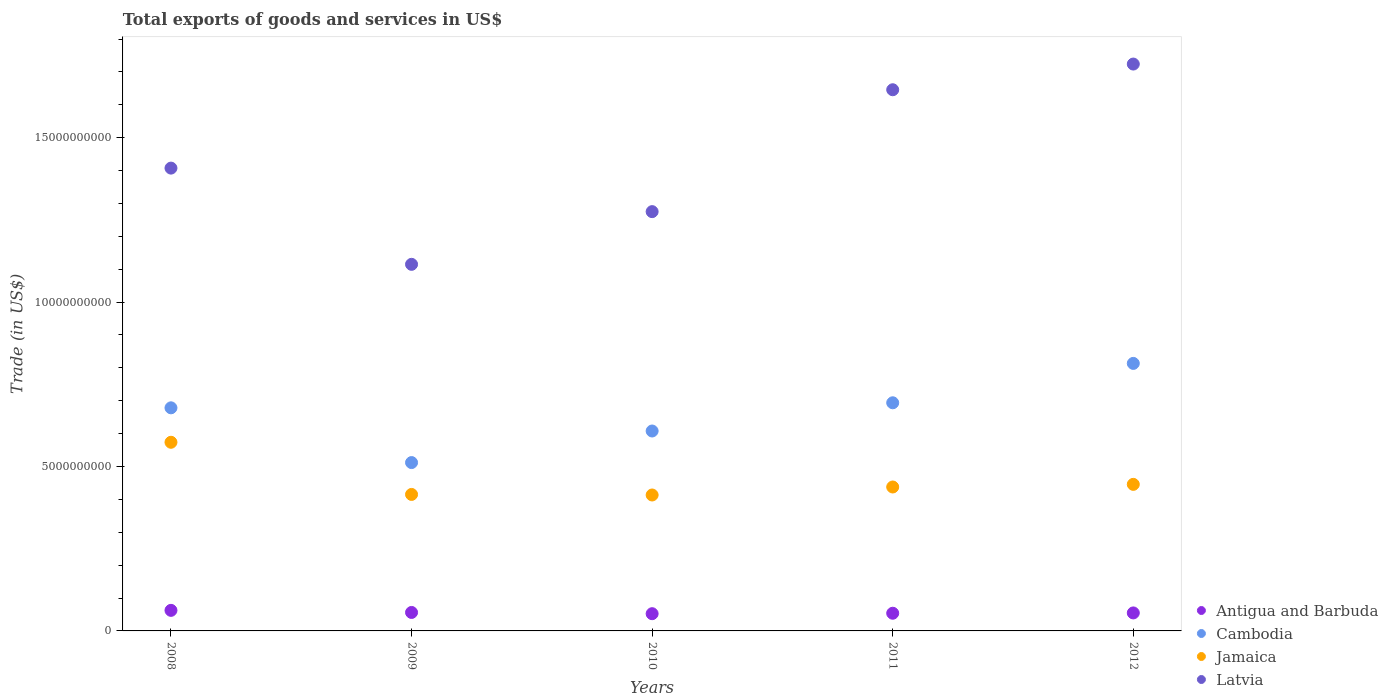Is the number of dotlines equal to the number of legend labels?
Your answer should be compact. Yes. What is the total exports of goods and services in Jamaica in 2010?
Your answer should be compact. 4.13e+09. Across all years, what is the maximum total exports of goods and services in Latvia?
Give a very brief answer. 1.72e+1. Across all years, what is the minimum total exports of goods and services in Antigua and Barbuda?
Your answer should be very brief. 5.24e+08. What is the total total exports of goods and services in Cambodia in the graph?
Keep it short and to the point. 3.31e+1. What is the difference between the total exports of goods and services in Antigua and Barbuda in 2011 and that in 2012?
Provide a succinct answer. -9.44e+06. What is the difference between the total exports of goods and services in Latvia in 2010 and the total exports of goods and services in Antigua and Barbuda in 2012?
Make the answer very short. 1.22e+1. What is the average total exports of goods and services in Jamaica per year?
Your answer should be very brief. 4.57e+09. In the year 2010, what is the difference between the total exports of goods and services in Jamaica and total exports of goods and services in Latvia?
Provide a short and direct response. -8.62e+09. What is the ratio of the total exports of goods and services in Jamaica in 2011 to that in 2012?
Make the answer very short. 0.98. Is the total exports of goods and services in Antigua and Barbuda in 2010 less than that in 2012?
Ensure brevity in your answer.  Yes. Is the difference between the total exports of goods and services in Jamaica in 2008 and 2009 greater than the difference between the total exports of goods and services in Latvia in 2008 and 2009?
Ensure brevity in your answer.  No. What is the difference between the highest and the second highest total exports of goods and services in Antigua and Barbuda?
Ensure brevity in your answer.  6.37e+07. What is the difference between the highest and the lowest total exports of goods and services in Latvia?
Give a very brief answer. 6.09e+09. Is it the case that in every year, the sum of the total exports of goods and services in Antigua and Barbuda and total exports of goods and services in Jamaica  is greater than the sum of total exports of goods and services in Latvia and total exports of goods and services in Cambodia?
Offer a terse response. No. Does the total exports of goods and services in Antigua and Barbuda monotonically increase over the years?
Give a very brief answer. No. Is the total exports of goods and services in Latvia strictly greater than the total exports of goods and services in Antigua and Barbuda over the years?
Make the answer very short. Yes. Is the total exports of goods and services in Latvia strictly less than the total exports of goods and services in Antigua and Barbuda over the years?
Your answer should be very brief. No. What is the difference between two consecutive major ticks on the Y-axis?
Your answer should be very brief. 5.00e+09. Are the values on the major ticks of Y-axis written in scientific E-notation?
Offer a terse response. No. Does the graph contain any zero values?
Offer a terse response. No. How are the legend labels stacked?
Your answer should be compact. Vertical. What is the title of the graph?
Provide a succinct answer. Total exports of goods and services in US$. What is the label or title of the Y-axis?
Your answer should be compact. Trade (in US$). What is the Trade (in US$) of Antigua and Barbuda in 2008?
Your answer should be compact. 6.25e+08. What is the Trade (in US$) of Cambodia in 2008?
Ensure brevity in your answer.  6.78e+09. What is the Trade (in US$) in Jamaica in 2008?
Keep it short and to the point. 5.74e+09. What is the Trade (in US$) in Latvia in 2008?
Provide a short and direct response. 1.41e+1. What is the Trade (in US$) in Antigua and Barbuda in 2009?
Ensure brevity in your answer.  5.62e+08. What is the Trade (in US$) of Cambodia in 2009?
Offer a terse response. 5.12e+09. What is the Trade (in US$) of Jamaica in 2009?
Provide a succinct answer. 4.15e+09. What is the Trade (in US$) in Latvia in 2009?
Your answer should be very brief. 1.11e+1. What is the Trade (in US$) in Antigua and Barbuda in 2010?
Keep it short and to the point. 5.24e+08. What is the Trade (in US$) in Cambodia in 2010?
Your response must be concise. 6.08e+09. What is the Trade (in US$) in Jamaica in 2010?
Your answer should be compact. 4.13e+09. What is the Trade (in US$) in Latvia in 2010?
Your response must be concise. 1.28e+1. What is the Trade (in US$) of Antigua and Barbuda in 2011?
Your answer should be compact. 5.38e+08. What is the Trade (in US$) in Cambodia in 2011?
Give a very brief answer. 6.94e+09. What is the Trade (in US$) in Jamaica in 2011?
Provide a succinct answer. 4.38e+09. What is the Trade (in US$) in Latvia in 2011?
Give a very brief answer. 1.65e+1. What is the Trade (in US$) of Antigua and Barbuda in 2012?
Make the answer very short. 5.47e+08. What is the Trade (in US$) of Cambodia in 2012?
Provide a short and direct response. 8.14e+09. What is the Trade (in US$) in Jamaica in 2012?
Offer a very short reply. 4.46e+09. What is the Trade (in US$) in Latvia in 2012?
Provide a succinct answer. 1.72e+1. Across all years, what is the maximum Trade (in US$) of Antigua and Barbuda?
Provide a succinct answer. 6.25e+08. Across all years, what is the maximum Trade (in US$) in Cambodia?
Make the answer very short. 8.14e+09. Across all years, what is the maximum Trade (in US$) in Jamaica?
Offer a terse response. 5.74e+09. Across all years, what is the maximum Trade (in US$) in Latvia?
Offer a terse response. 1.72e+1. Across all years, what is the minimum Trade (in US$) in Antigua and Barbuda?
Make the answer very short. 5.24e+08. Across all years, what is the minimum Trade (in US$) in Cambodia?
Make the answer very short. 5.12e+09. Across all years, what is the minimum Trade (in US$) in Jamaica?
Offer a very short reply. 4.13e+09. Across all years, what is the minimum Trade (in US$) in Latvia?
Your answer should be very brief. 1.11e+1. What is the total Trade (in US$) of Antigua and Barbuda in the graph?
Provide a short and direct response. 2.80e+09. What is the total Trade (in US$) in Cambodia in the graph?
Provide a succinct answer. 3.31e+1. What is the total Trade (in US$) in Jamaica in the graph?
Ensure brevity in your answer.  2.29e+1. What is the total Trade (in US$) of Latvia in the graph?
Give a very brief answer. 7.17e+1. What is the difference between the Trade (in US$) of Antigua and Barbuda in 2008 and that in 2009?
Keep it short and to the point. 6.37e+07. What is the difference between the Trade (in US$) of Cambodia in 2008 and that in 2009?
Your answer should be compact. 1.67e+09. What is the difference between the Trade (in US$) of Jamaica in 2008 and that in 2009?
Give a very brief answer. 1.59e+09. What is the difference between the Trade (in US$) of Latvia in 2008 and that in 2009?
Keep it short and to the point. 2.93e+09. What is the difference between the Trade (in US$) in Antigua and Barbuda in 2008 and that in 2010?
Your response must be concise. 1.02e+08. What is the difference between the Trade (in US$) in Cambodia in 2008 and that in 2010?
Ensure brevity in your answer.  7.05e+08. What is the difference between the Trade (in US$) in Jamaica in 2008 and that in 2010?
Keep it short and to the point. 1.60e+09. What is the difference between the Trade (in US$) of Latvia in 2008 and that in 2010?
Make the answer very short. 1.32e+09. What is the difference between the Trade (in US$) in Antigua and Barbuda in 2008 and that in 2011?
Provide a succinct answer. 8.76e+07. What is the difference between the Trade (in US$) of Cambodia in 2008 and that in 2011?
Your answer should be very brief. -1.53e+08. What is the difference between the Trade (in US$) in Jamaica in 2008 and that in 2011?
Your response must be concise. 1.36e+09. What is the difference between the Trade (in US$) in Latvia in 2008 and that in 2011?
Provide a short and direct response. -2.38e+09. What is the difference between the Trade (in US$) in Antigua and Barbuda in 2008 and that in 2012?
Your response must be concise. 7.82e+07. What is the difference between the Trade (in US$) in Cambodia in 2008 and that in 2012?
Provide a succinct answer. -1.35e+09. What is the difference between the Trade (in US$) in Jamaica in 2008 and that in 2012?
Give a very brief answer. 1.28e+09. What is the difference between the Trade (in US$) of Latvia in 2008 and that in 2012?
Offer a terse response. -3.16e+09. What is the difference between the Trade (in US$) in Antigua and Barbuda in 2009 and that in 2010?
Your answer should be very brief. 3.78e+07. What is the difference between the Trade (in US$) in Cambodia in 2009 and that in 2010?
Your response must be concise. -9.60e+08. What is the difference between the Trade (in US$) of Jamaica in 2009 and that in 2010?
Offer a very short reply. 1.70e+07. What is the difference between the Trade (in US$) of Latvia in 2009 and that in 2010?
Provide a succinct answer. -1.60e+09. What is the difference between the Trade (in US$) of Antigua and Barbuda in 2009 and that in 2011?
Offer a very short reply. 2.39e+07. What is the difference between the Trade (in US$) in Cambodia in 2009 and that in 2011?
Ensure brevity in your answer.  -1.82e+09. What is the difference between the Trade (in US$) of Jamaica in 2009 and that in 2011?
Your response must be concise. -2.26e+08. What is the difference between the Trade (in US$) in Latvia in 2009 and that in 2011?
Your answer should be compact. -5.31e+09. What is the difference between the Trade (in US$) of Antigua and Barbuda in 2009 and that in 2012?
Your response must be concise. 1.44e+07. What is the difference between the Trade (in US$) in Cambodia in 2009 and that in 2012?
Offer a terse response. -3.02e+09. What is the difference between the Trade (in US$) in Jamaica in 2009 and that in 2012?
Give a very brief answer. -3.06e+08. What is the difference between the Trade (in US$) in Latvia in 2009 and that in 2012?
Provide a succinct answer. -6.09e+09. What is the difference between the Trade (in US$) of Antigua and Barbuda in 2010 and that in 2011?
Provide a succinct answer. -1.39e+07. What is the difference between the Trade (in US$) in Cambodia in 2010 and that in 2011?
Ensure brevity in your answer.  -8.58e+08. What is the difference between the Trade (in US$) in Jamaica in 2010 and that in 2011?
Your answer should be compact. -2.43e+08. What is the difference between the Trade (in US$) in Latvia in 2010 and that in 2011?
Ensure brevity in your answer.  -3.71e+09. What is the difference between the Trade (in US$) of Antigua and Barbuda in 2010 and that in 2012?
Your answer should be very brief. -2.34e+07. What is the difference between the Trade (in US$) in Cambodia in 2010 and that in 2012?
Your answer should be very brief. -2.06e+09. What is the difference between the Trade (in US$) in Jamaica in 2010 and that in 2012?
Make the answer very short. -3.23e+08. What is the difference between the Trade (in US$) in Latvia in 2010 and that in 2012?
Give a very brief answer. -4.49e+09. What is the difference between the Trade (in US$) of Antigua and Barbuda in 2011 and that in 2012?
Your answer should be very brief. -9.44e+06. What is the difference between the Trade (in US$) in Cambodia in 2011 and that in 2012?
Offer a very short reply. -1.20e+09. What is the difference between the Trade (in US$) of Jamaica in 2011 and that in 2012?
Ensure brevity in your answer.  -8.01e+07. What is the difference between the Trade (in US$) in Latvia in 2011 and that in 2012?
Keep it short and to the point. -7.81e+08. What is the difference between the Trade (in US$) of Antigua and Barbuda in 2008 and the Trade (in US$) of Cambodia in 2009?
Provide a succinct answer. -4.49e+09. What is the difference between the Trade (in US$) of Antigua and Barbuda in 2008 and the Trade (in US$) of Jamaica in 2009?
Provide a succinct answer. -3.53e+09. What is the difference between the Trade (in US$) in Antigua and Barbuda in 2008 and the Trade (in US$) in Latvia in 2009?
Ensure brevity in your answer.  -1.05e+1. What is the difference between the Trade (in US$) in Cambodia in 2008 and the Trade (in US$) in Jamaica in 2009?
Keep it short and to the point. 2.63e+09. What is the difference between the Trade (in US$) in Cambodia in 2008 and the Trade (in US$) in Latvia in 2009?
Offer a terse response. -4.36e+09. What is the difference between the Trade (in US$) of Jamaica in 2008 and the Trade (in US$) of Latvia in 2009?
Give a very brief answer. -5.41e+09. What is the difference between the Trade (in US$) of Antigua and Barbuda in 2008 and the Trade (in US$) of Cambodia in 2010?
Keep it short and to the point. -5.45e+09. What is the difference between the Trade (in US$) of Antigua and Barbuda in 2008 and the Trade (in US$) of Jamaica in 2010?
Give a very brief answer. -3.51e+09. What is the difference between the Trade (in US$) in Antigua and Barbuda in 2008 and the Trade (in US$) in Latvia in 2010?
Give a very brief answer. -1.21e+1. What is the difference between the Trade (in US$) in Cambodia in 2008 and the Trade (in US$) in Jamaica in 2010?
Offer a terse response. 2.65e+09. What is the difference between the Trade (in US$) in Cambodia in 2008 and the Trade (in US$) in Latvia in 2010?
Provide a succinct answer. -5.97e+09. What is the difference between the Trade (in US$) of Jamaica in 2008 and the Trade (in US$) of Latvia in 2010?
Provide a succinct answer. -7.01e+09. What is the difference between the Trade (in US$) in Antigua and Barbuda in 2008 and the Trade (in US$) in Cambodia in 2011?
Provide a short and direct response. -6.31e+09. What is the difference between the Trade (in US$) of Antigua and Barbuda in 2008 and the Trade (in US$) of Jamaica in 2011?
Ensure brevity in your answer.  -3.75e+09. What is the difference between the Trade (in US$) of Antigua and Barbuda in 2008 and the Trade (in US$) of Latvia in 2011?
Offer a terse response. -1.58e+1. What is the difference between the Trade (in US$) of Cambodia in 2008 and the Trade (in US$) of Jamaica in 2011?
Ensure brevity in your answer.  2.41e+09. What is the difference between the Trade (in US$) of Cambodia in 2008 and the Trade (in US$) of Latvia in 2011?
Your answer should be compact. -9.67e+09. What is the difference between the Trade (in US$) in Jamaica in 2008 and the Trade (in US$) in Latvia in 2011?
Ensure brevity in your answer.  -1.07e+1. What is the difference between the Trade (in US$) of Antigua and Barbuda in 2008 and the Trade (in US$) of Cambodia in 2012?
Your response must be concise. -7.51e+09. What is the difference between the Trade (in US$) of Antigua and Barbuda in 2008 and the Trade (in US$) of Jamaica in 2012?
Ensure brevity in your answer.  -3.83e+09. What is the difference between the Trade (in US$) of Antigua and Barbuda in 2008 and the Trade (in US$) of Latvia in 2012?
Your answer should be compact. -1.66e+1. What is the difference between the Trade (in US$) of Cambodia in 2008 and the Trade (in US$) of Jamaica in 2012?
Make the answer very short. 2.33e+09. What is the difference between the Trade (in US$) of Cambodia in 2008 and the Trade (in US$) of Latvia in 2012?
Give a very brief answer. -1.05e+1. What is the difference between the Trade (in US$) of Jamaica in 2008 and the Trade (in US$) of Latvia in 2012?
Keep it short and to the point. -1.15e+1. What is the difference between the Trade (in US$) of Antigua and Barbuda in 2009 and the Trade (in US$) of Cambodia in 2010?
Your answer should be compact. -5.52e+09. What is the difference between the Trade (in US$) in Antigua and Barbuda in 2009 and the Trade (in US$) in Jamaica in 2010?
Offer a very short reply. -3.57e+09. What is the difference between the Trade (in US$) of Antigua and Barbuda in 2009 and the Trade (in US$) of Latvia in 2010?
Give a very brief answer. -1.22e+1. What is the difference between the Trade (in US$) of Cambodia in 2009 and the Trade (in US$) of Jamaica in 2010?
Give a very brief answer. 9.86e+08. What is the difference between the Trade (in US$) in Cambodia in 2009 and the Trade (in US$) in Latvia in 2010?
Your answer should be compact. -7.63e+09. What is the difference between the Trade (in US$) of Jamaica in 2009 and the Trade (in US$) of Latvia in 2010?
Give a very brief answer. -8.60e+09. What is the difference between the Trade (in US$) in Antigua and Barbuda in 2009 and the Trade (in US$) in Cambodia in 2011?
Ensure brevity in your answer.  -6.38e+09. What is the difference between the Trade (in US$) in Antigua and Barbuda in 2009 and the Trade (in US$) in Jamaica in 2011?
Your response must be concise. -3.82e+09. What is the difference between the Trade (in US$) in Antigua and Barbuda in 2009 and the Trade (in US$) in Latvia in 2011?
Offer a very short reply. -1.59e+1. What is the difference between the Trade (in US$) in Cambodia in 2009 and the Trade (in US$) in Jamaica in 2011?
Keep it short and to the point. 7.43e+08. What is the difference between the Trade (in US$) of Cambodia in 2009 and the Trade (in US$) of Latvia in 2011?
Offer a terse response. -1.13e+1. What is the difference between the Trade (in US$) of Jamaica in 2009 and the Trade (in US$) of Latvia in 2011?
Make the answer very short. -1.23e+1. What is the difference between the Trade (in US$) of Antigua and Barbuda in 2009 and the Trade (in US$) of Cambodia in 2012?
Your answer should be very brief. -7.57e+09. What is the difference between the Trade (in US$) of Antigua and Barbuda in 2009 and the Trade (in US$) of Jamaica in 2012?
Your answer should be very brief. -3.90e+09. What is the difference between the Trade (in US$) of Antigua and Barbuda in 2009 and the Trade (in US$) of Latvia in 2012?
Keep it short and to the point. -1.67e+1. What is the difference between the Trade (in US$) in Cambodia in 2009 and the Trade (in US$) in Jamaica in 2012?
Your answer should be very brief. 6.63e+08. What is the difference between the Trade (in US$) of Cambodia in 2009 and the Trade (in US$) of Latvia in 2012?
Make the answer very short. -1.21e+1. What is the difference between the Trade (in US$) in Jamaica in 2009 and the Trade (in US$) in Latvia in 2012?
Your answer should be compact. -1.31e+1. What is the difference between the Trade (in US$) of Antigua and Barbuda in 2010 and the Trade (in US$) of Cambodia in 2011?
Offer a terse response. -6.41e+09. What is the difference between the Trade (in US$) of Antigua and Barbuda in 2010 and the Trade (in US$) of Jamaica in 2011?
Your response must be concise. -3.85e+09. What is the difference between the Trade (in US$) of Antigua and Barbuda in 2010 and the Trade (in US$) of Latvia in 2011?
Your answer should be very brief. -1.59e+1. What is the difference between the Trade (in US$) of Cambodia in 2010 and the Trade (in US$) of Jamaica in 2011?
Offer a terse response. 1.70e+09. What is the difference between the Trade (in US$) of Cambodia in 2010 and the Trade (in US$) of Latvia in 2011?
Offer a terse response. -1.04e+1. What is the difference between the Trade (in US$) of Jamaica in 2010 and the Trade (in US$) of Latvia in 2011?
Give a very brief answer. -1.23e+1. What is the difference between the Trade (in US$) of Antigua and Barbuda in 2010 and the Trade (in US$) of Cambodia in 2012?
Your answer should be compact. -7.61e+09. What is the difference between the Trade (in US$) in Antigua and Barbuda in 2010 and the Trade (in US$) in Jamaica in 2012?
Ensure brevity in your answer.  -3.93e+09. What is the difference between the Trade (in US$) of Antigua and Barbuda in 2010 and the Trade (in US$) of Latvia in 2012?
Provide a short and direct response. -1.67e+1. What is the difference between the Trade (in US$) of Cambodia in 2010 and the Trade (in US$) of Jamaica in 2012?
Ensure brevity in your answer.  1.62e+09. What is the difference between the Trade (in US$) in Cambodia in 2010 and the Trade (in US$) in Latvia in 2012?
Keep it short and to the point. -1.12e+1. What is the difference between the Trade (in US$) of Jamaica in 2010 and the Trade (in US$) of Latvia in 2012?
Your response must be concise. -1.31e+1. What is the difference between the Trade (in US$) in Antigua and Barbuda in 2011 and the Trade (in US$) in Cambodia in 2012?
Give a very brief answer. -7.60e+09. What is the difference between the Trade (in US$) of Antigua and Barbuda in 2011 and the Trade (in US$) of Jamaica in 2012?
Provide a succinct answer. -3.92e+09. What is the difference between the Trade (in US$) of Antigua and Barbuda in 2011 and the Trade (in US$) of Latvia in 2012?
Provide a short and direct response. -1.67e+1. What is the difference between the Trade (in US$) of Cambodia in 2011 and the Trade (in US$) of Jamaica in 2012?
Make the answer very short. 2.48e+09. What is the difference between the Trade (in US$) of Cambodia in 2011 and the Trade (in US$) of Latvia in 2012?
Keep it short and to the point. -1.03e+1. What is the difference between the Trade (in US$) in Jamaica in 2011 and the Trade (in US$) in Latvia in 2012?
Make the answer very short. -1.29e+1. What is the average Trade (in US$) of Antigua and Barbuda per year?
Keep it short and to the point. 5.59e+08. What is the average Trade (in US$) in Cambodia per year?
Make the answer very short. 6.61e+09. What is the average Trade (in US$) of Jamaica per year?
Ensure brevity in your answer.  4.57e+09. What is the average Trade (in US$) of Latvia per year?
Your answer should be compact. 1.43e+1. In the year 2008, what is the difference between the Trade (in US$) in Antigua and Barbuda and Trade (in US$) in Cambodia?
Keep it short and to the point. -6.16e+09. In the year 2008, what is the difference between the Trade (in US$) in Antigua and Barbuda and Trade (in US$) in Jamaica?
Offer a terse response. -5.11e+09. In the year 2008, what is the difference between the Trade (in US$) of Antigua and Barbuda and Trade (in US$) of Latvia?
Provide a short and direct response. -1.35e+1. In the year 2008, what is the difference between the Trade (in US$) of Cambodia and Trade (in US$) of Jamaica?
Make the answer very short. 1.05e+09. In the year 2008, what is the difference between the Trade (in US$) in Cambodia and Trade (in US$) in Latvia?
Provide a short and direct response. -7.29e+09. In the year 2008, what is the difference between the Trade (in US$) of Jamaica and Trade (in US$) of Latvia?
Your answer should be very brief. -8.34e+09. In the year 2009, what is the difference between the Trade (in US$) of Antigua and Barbuda and Trade (in US$) of Cambodia?
Provide a succinct answer. -4.56e+09. In the year 2009, what is the difference between the Trade (in US$) of Antigua and Barbuda and Trade (in US$) of Jamaica?
Provide a short and direct response. -3.59e+09. In the year 2009, what is the difference between the Trade (in US$) in Antigua and Barbuda and Trade (in US$) in Latvia?
Offer a very short reply. -1.06e+1. In the year 2009, what is the difference between the Trade (in US$) in Cambodia and Trade (in US$) in Jamaica?
Provide a short and direct response. 9.69e+08. In the year 2009, what is the difference between the Trade (in US$) of Cambodia and Trade (in US$) of Latvia?
Provide a short and direct response. -6.03e+09. In the year 2009, what is the difference between the Trade (in US$) in Jamaica and Trade (in US$) in Latvia?
Give a very brief answer. -7.00e+09. In the year 2010, what is the difference between the Trade (in US$) of Antigua and Barbuda and Trade (in US$) of Cambodia?
Offer a very short reply. -5.56e+09. In the year 2010, what is the difference between the Trade (in US$) in Antigua and Barbuda and Trade (in US$) in Jamaica?
Make the answer very short. -3.61e+09. In the year 2010, what is the difference between the Trade (in US$) in Antigua and Barbuda and Trade (in US$) in Latvia?
Ensure brevity in your answer.  -1.22e+1. In the year 2010, what is the difference between the Trade (in US$) in Cambodia and Trade (in US$) in Jamaica?
Provide a succinct answer. 1.95e+09. In the year 2010, what is the difference between the Trade (in US$) of Cambodia and Trade (in US$) of Latvia?
Your answer should be compact. -6.67e+09. In the year 2010, what is the difference between the Trade (in US$) of Jamaica and Trade (in US$) of Latvia?
Give a very brief answer. -8.62e+09. In the year 2011, what is the difference between the Trade (in US$) of Antigua and Barbuda and Trade (in US$) of Cambodia?
Your response must be concise. -6.40e+09. In the year 2011, what is the difference between the Trade (in US$) of Antigua and Barbuda and Trade (in US$) of Jamaica?
Ensure brevity in your answer.  -3.84e+09. In the year 2011, what is the difference between the Trade (in US$) of Antigua and Barbuda and Trade (in US$) of Latvia?
Your answer should be very brief. -1.59e+1. In the year 2011, what is the difference between the Trade (in US$) in Cambodia and Trade (in US$) in Jamaica?
Offer a very short reply. 2.56e+09. In the year 2011, what is the difference between the Trade (in US$) in Cambodia and Trade (in US$) in Latvia?
Your response must be concise. -9.52e+09. In the year 2011, what is the difference between the Trade (in US$) in Jamaica and Trade (in US$) in Latvia?
Keep it short and to the point. -1.21e+1. In the year 2012, what is the difference between the Trade (in US$) in Antigua and Barbuda and Trade (in US$) in Cambodia?
Offer a terse response. -7.59e+09. In the year 2012, what is the difference between the Trade (in US$) in Antigua and Barbuda and Trade (in US$) in Jamaica?
Your response must be concise. -3.91e+09. In the year 2012, what is the difference between the Trade (in US$) of Antigua and Barbuda and Trade (in US$) of Latvia?
Offer a terse response. -1.67e+1. In the year 2012, what is the difference between the Trade (in US$) in Cambodia and Trade (in US$) in Jamaica?
Your response must be concise. 3.68e+09. In the year 2012, what is the difference between the Trade (in US$) of Cambodia and Trade (in US$) of Latvia?
Provide a succinct answer. -9.10e+09. In the year 2012, what is the difference between the Trade (in US$) in Jamaica and Trade (in US$) in Latvia?
Keep it short and to the point. -1.28e+1. What is the ratio of the Trade (in US$) of Antigua and Barbuda in 2008 to that in 2009?
Provide a short and direct response. 1.11. What is the ratio of the Trade (in US$) in Cambodia in 2008 to that in 2009?
Give a very brief answer. 1.33. What is the ratio of the Trade (in US$) in Jamaica in 2008 to that in 2009?
Give a very brief answer. 1.38. What is the ratio of the Trade (in US$) of Latvia in 2008 to that in 2009?
Provide a succinct answer. 1.26. What is the ratio of the Trade (in US$) of Antigua and Barbuda in 2008 to that in 2010?
Provide a succinct answer. 1.19. What is the ratio of the Trade (in US$) in Cambodia in 2008 to that in 2010?
Offer a very short reply. 1.12. What is the ratio of the Trade (in US$) in Jamaica in 2008 to that in 2010?
Provide a short and direct response. 1.39. What is the ratio of the Trade (in US$) of Latvia in 2008 to that in 2010?
Your response must be concise. 1.1. What is the ratio of the Trade (in US$) in Antigua and Barbuda in 2008 to that in 2011?
Offer a very short reply. 1.16. What is the ratio of the Trade (in US$) in Cambodia in 2008 to that in 2011?
Give a very brief answer. 0.98. What is the ratio of the Trade (in US$) of Jamaica in 2008 to that in 2011?
Provide a succinct answer. 1.31. What is the ratio of the Trade (in US$) of Latvia in 2008 to that in 2011?
Ensure brevity in your answer.  0.86. What is the ratio of the Trade (in US$) of Cambodia in 2008 to that in 2012?
Your response must be concise. 0.83. What is the ratio of the Trade (in US$) of Jamaica in 2008 to that in 2012?
Ensure brevity in your answer.  1.29. What is the ratio of the Trade (in US$) in Latvia in 2008 to that in 2012?
Offer a terse response. 0.82. What is the ratio of the Trade (in US$) in Antigua and Barbuda in 2009 to that in 2010?
Give a very brief answer. 1.07. What is the ratio of the Trade (in US$) of Cambodia in 2009 to that in 2010?
Ensure brevity in your answer.  0.84. What is the ratio of the Trade (in US$) in Latvia in 2009 to that in 2010?
Your answer should be compact. 0.87. What is the ratio of the Trade (in US$) in Antigua and Barbuda in 2009 to that in 2011?
Your answer should be compact. 1.04. What is the ratio of the Trade (in US$) of Cambodia in 2009 to that in 2011?
Your answer should be very brief. 0.74. What is the ratio of the Trade (in US$) in Jamaica in 2009 to that in 2011?
Your answer should be very brief. 0.95. What is the ratio of the Trade (in US$) in Latvia in 2009 to that in 2011?
Your response must be concise. 0.68. What is the ratio of the Trade (in US$) in Antigua and Barbuda in 2009 to that in 2012?
Your response must be concise. 1.03. What is the ratio of the Trade (in US$) of Cambodia in 2009 to that in 2012?
Your answer should be very brief. 0.63. What is the ratio of the Trade (in US$) in Jamaica in 2009 to that in 2012?
Make the answer very short. 0.93. What is the ratio of the Trade (in US$) of Latvia in 2009 to that in 2012?
Offer a very short reply. 0.65. What is the ratio of the Trade (in US$) in Antigua and Barbuda in 2010 to that in 2011?
Offer a terse response. 0.97. What is the ratio of the Trade (in US$) of Cambodia in 2010 to that in 2011?
Offer a terse response. 0.88. What is the ratio of the Trade (in US$) of Jamaica in 2010 to that in 2011?
Provide a succinct answer. 0.94. What is the ratio of the Trade (in US$) of Latvia in 2010 to that in 2011?
Your answer should be very brief. 0.77. What is the ratio of the Trade (in US$) in Antigua and Barbuda in 2010 to that in 2012?
Keep it short and to the point. 0.96. What is the ratio of the Trade (in US$) in Cambodia in 2010 to that in 2012?
Make the answer very short. 0.75. What is the ratio of the Trade (in US$) of Jamaica in 2010 to that in 2012?
Your response must be concise. 0.93. What is the ratio of the Trade (in US$) in Latvia in 2010 to that in 2012?
Ensure brevity in your answer.  0.74. What is the ratio of the Trade (in US$) of Antigua and Barbuda in 2011 to that in 2012?
Offer a terse response. 0.98. What is the ratio of the Trade (in US$) in Cambodia in 2011 to that in 2012?
Make the answer very short. 0.85. What is the ratio of the Trade (in US$) of Latvia in 2011 to that in 2012?
Offer a very short reply. 0.95. What is the difference between the highest and the second highest Trade (in US$) in Antigua and Barbuda?
Offer a terse response. 6.37e+07. What is the difference between the highest and the second highest Trade (in US$) of Cambodia?
Provide a short and direct response. 1.20e+09. What is the difference between the highest and the second highest Trade (in US$) in Jamaica?
Provide a short and direct response. 1.28e+09. What is the difference between the highest and the second highest Trade (in US$) in Latvia?
Give a very brief answer. 7.81e+08. What is the difference between the highest and the lowest Trade (in US$) in Antigua and Barbuda?
Your response must be concise. 1.02e+08. What is the difference between the highest and the lowest Trade (in US$) of Cambodia?
Make the answer very short. 3.02e+09. What is the difference between the highest and the lowest Trade (in US$) of Jamaica?
Offer a very short reply. 1.60e+09. What is the difference between the highest and the lowest Trade (in US$) of Latvia?
Provide a succinct answer. 6.09e+09. 